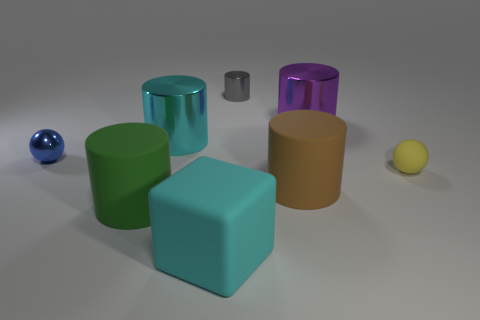Are there any other cyan rubber objects that have the same shape as the small rubber thing?
Offer a terse response. No. There is a matte sphere that is the same size as the gray shiny cylinder; what is its color?
Your answer should be very brief. Yellow. What material is the cyan object that is behind the big cube?
Your answer should be compact. Metal. There is a small thing left of the large cyan matte block; is it the same shape as the big cyan object that is in front of the brown object?
Make the answer very short. No. Are there the same number of blue metallic things that are left of the big brown rubber cylinder and small matte objects?
Provide a succinct answer. Yes. What number of tiny cyan cubes have the same material as the cyan cylinder?
Keep it short and to the point. 0. The small object that is the same material as the gray cylinder is what color?
Provide a succinct answer. Blue. Do the cube and the shiny cylinder in front of the purple cylinder have the same size?
Make the answer very short. Yes. There is a yellow matte thing; what shape is it?
Provide a succinct answer. Sphere. What number of tiny shiny objects have the same color as the metallic ball?
Provide a succinct answer. 0. 